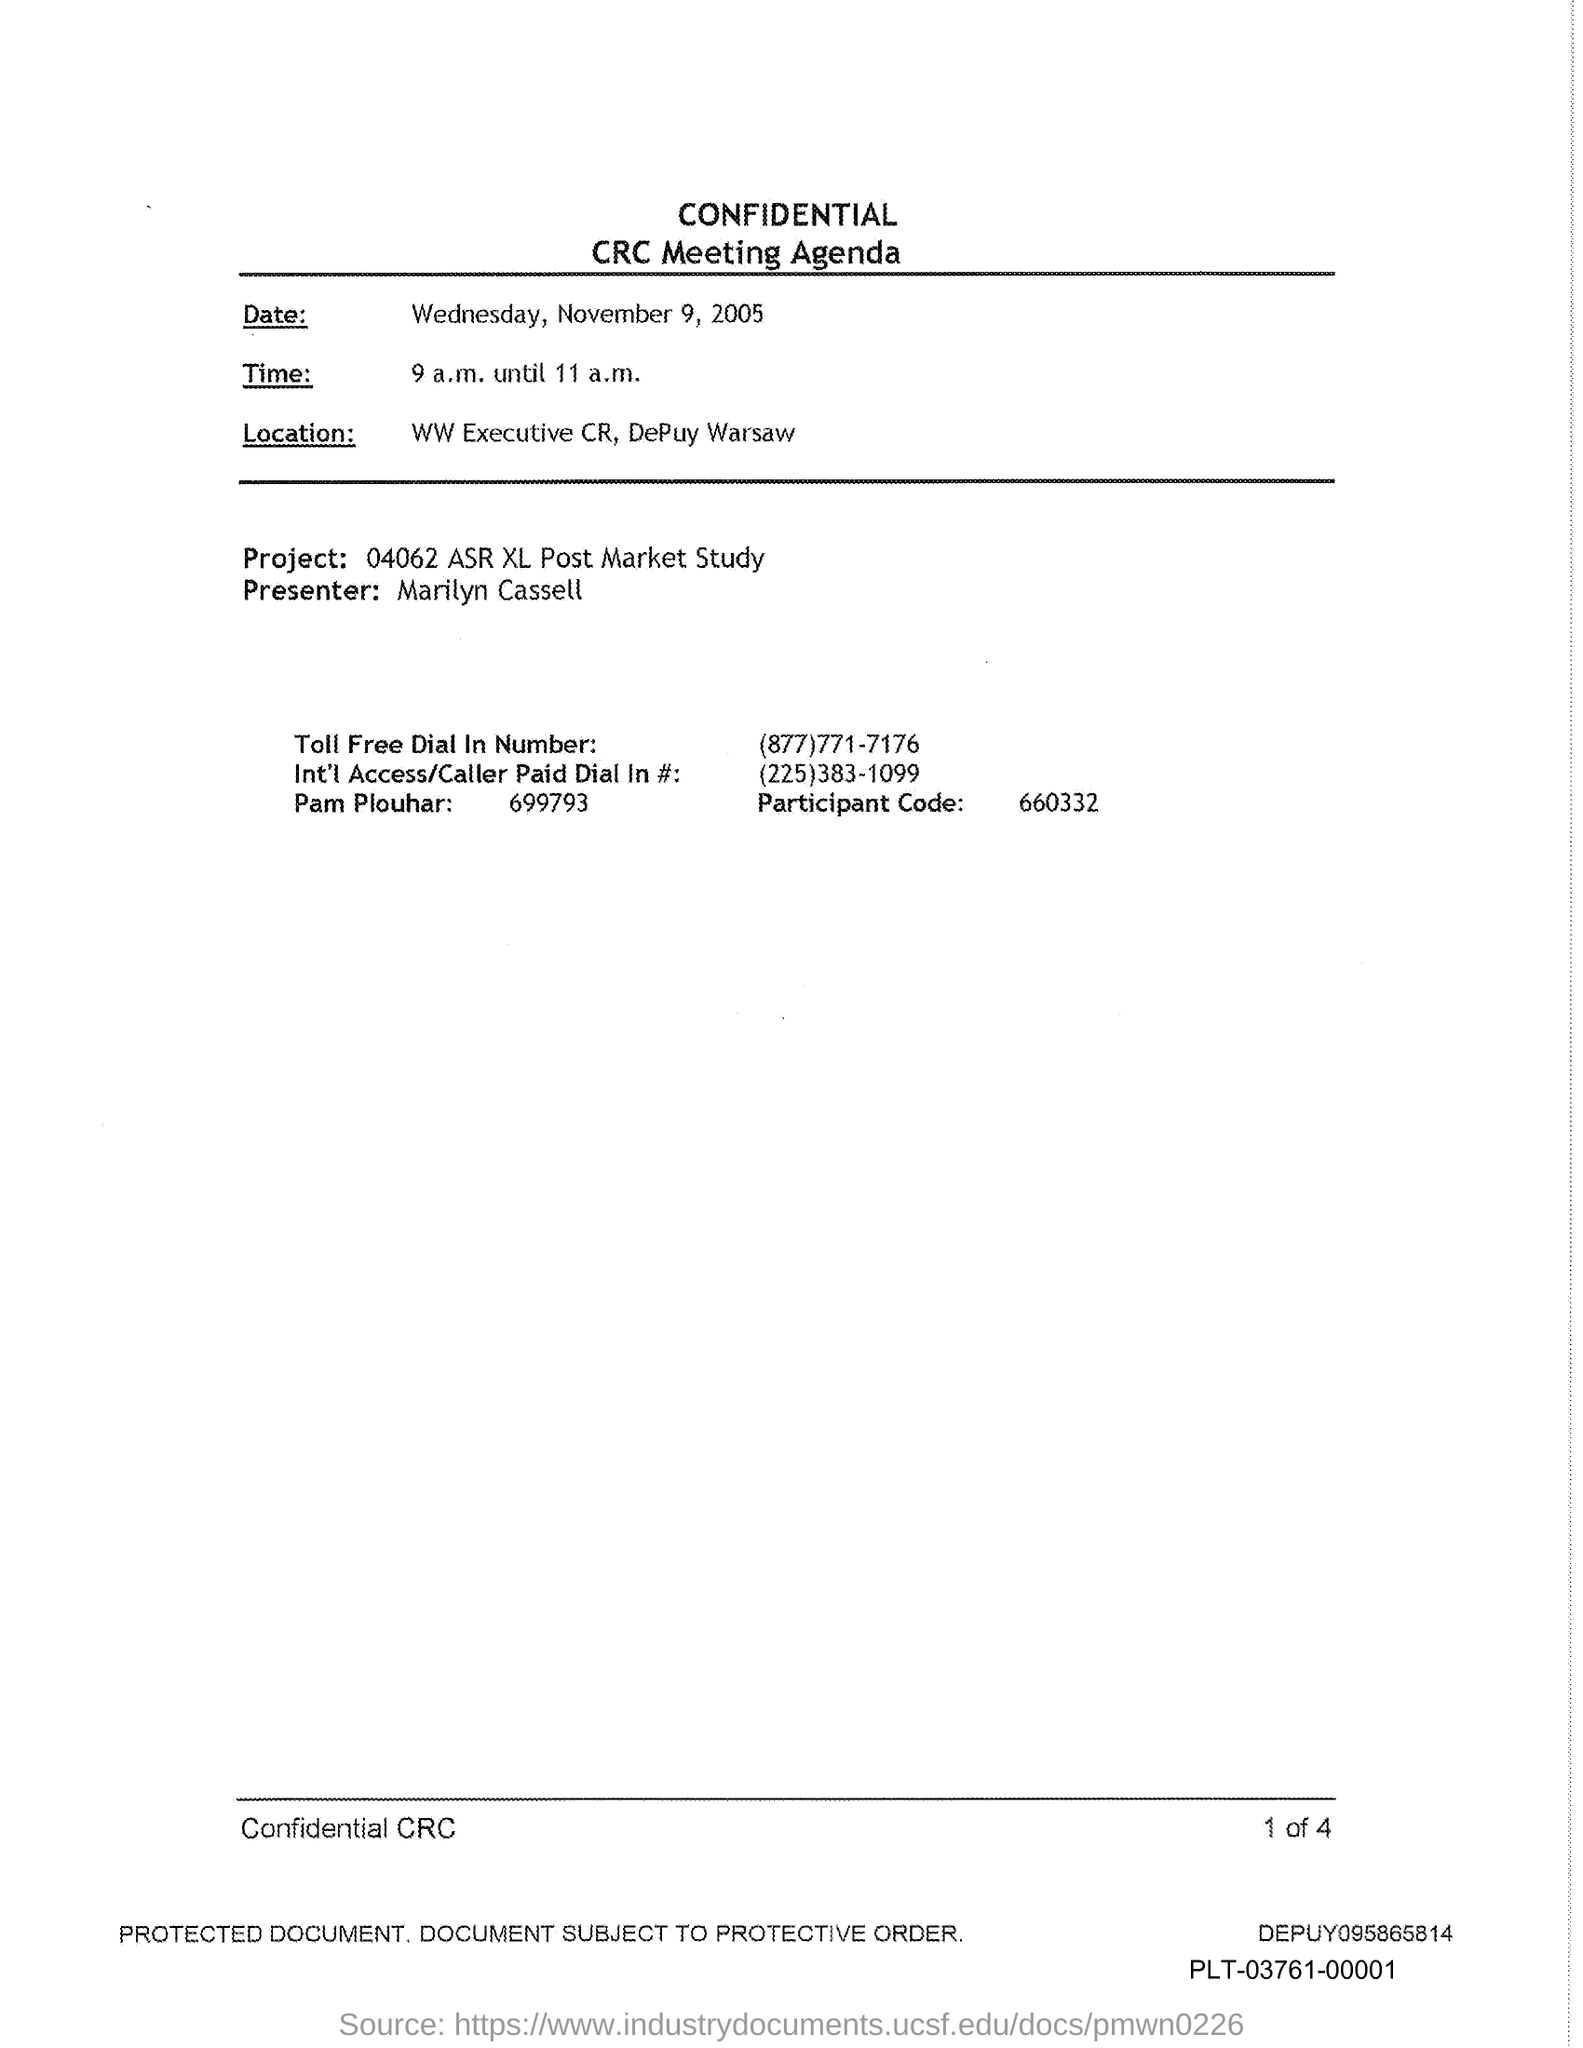Who is the Presenter?
Your response must be concise. Marilyn Cassell. What is the Participant Code?
Your answer should be compact. 660332. 